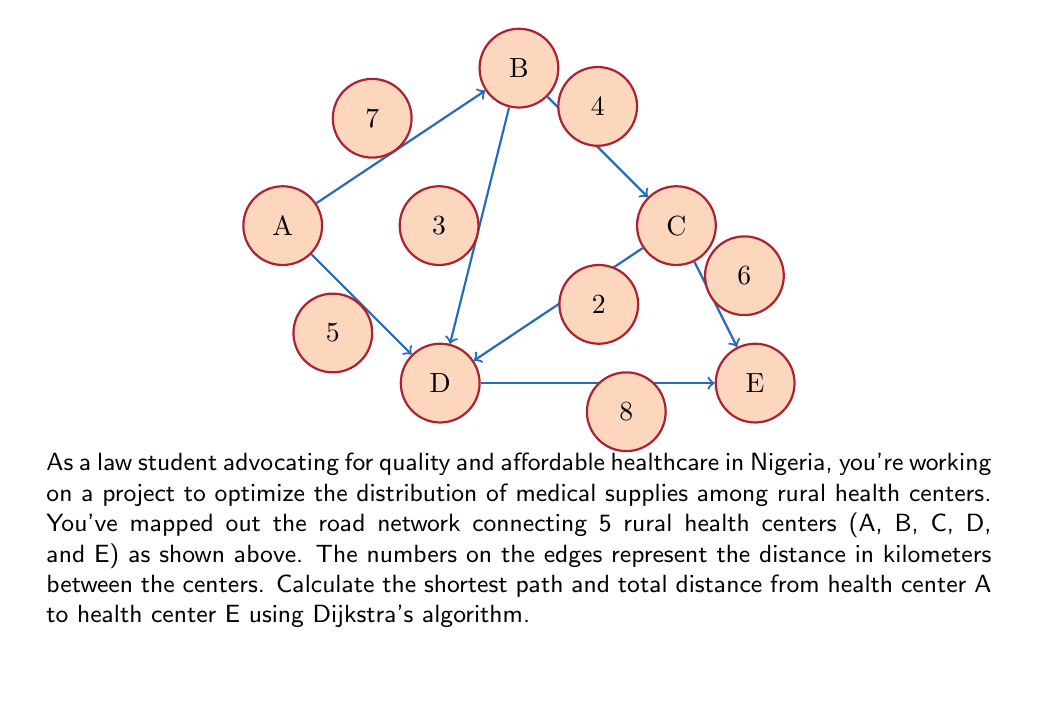Provide a solution to this math problem. To solve this problem using Dijkstra's algorithm, we'll follow these steps:

1) Initialize:
   - Set distance to A as 0 and all others as infinity.
   - Set all nodes as unvisited.
   - Set A as the current node.

2) For the current node, calculate the distance to all unvisited neighbors:
   - To B: 0 + 7 = 7
   - To D: 0 + 5 = 5

3) Update distances if shorter path found and set D as current (shortest distance).

4) From D, calculate distances:
   - To B: 5 + 3 = 8 (longer than existing, ignore)
   - To C: 5 + 2 = 7
   - To E: 5 + 8 = 13

5) Update distances and set C as current.

6) From C, calculate distances:
   - To B: 7 + 4 = 11 (longer, ignore)
   - To E: 7 + 6 = 13 (same as existing)

7) Set E as current. All nodes visited, algorithm complete.

The shortest path is A -> D -> C -> E with a total distance of 13 km.

Mathematically, we can represent this as:

$$d(A,E) = \min\{d(A,D) + d(D,C) + d(C,E), d(A,D) + d(D,E), d(A,B) + d(B,C) + d(C,E)\}$$
$$d(A,E) = \min\{5 + 2 + 6, 5 + 8, 7 + 4 + 6\}$$
$$d(A,E) = \min\{13, 13, 17\} = 13$$
Answer: Shortest path: A -> D -> C -> E; Total distance: 13 km 